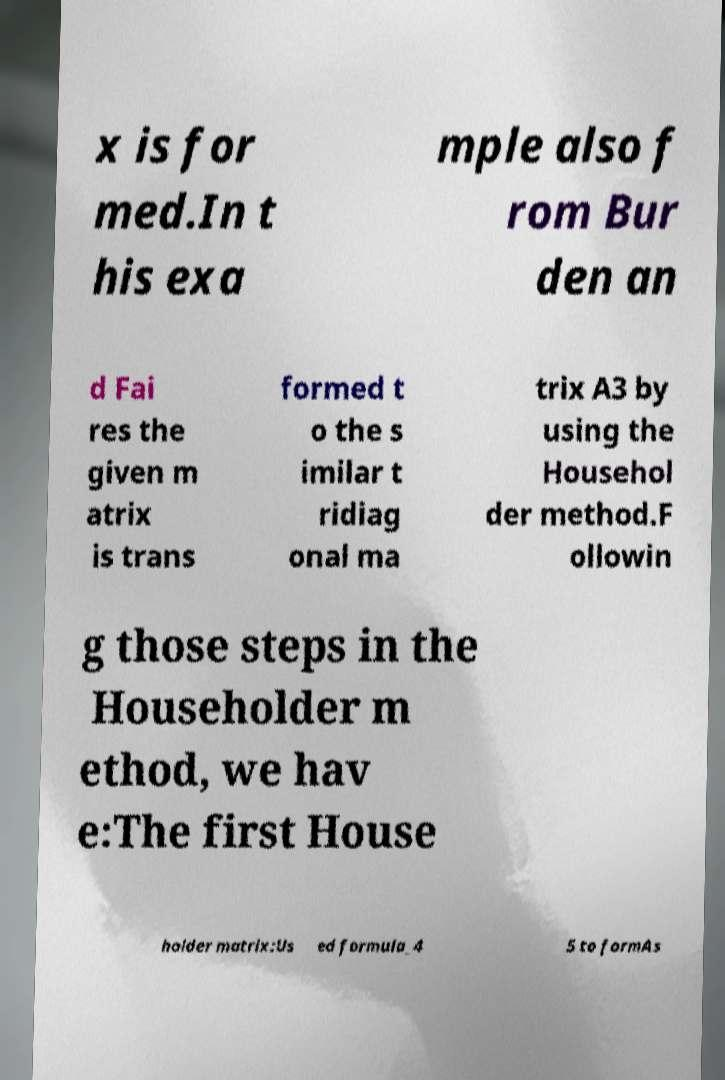Could you extract and type out the text from this image? x is for med.In t his exa mple also f rom Bur den an d Fai res the given m atrix is trans formed t o the s imilar t ridiag onal ma trix A3 by using the Househol der method.F ollowin g those steps in the Householder m ethod, we hav e:The first House holder matrix:Us ed formula_4 5 to formAs 